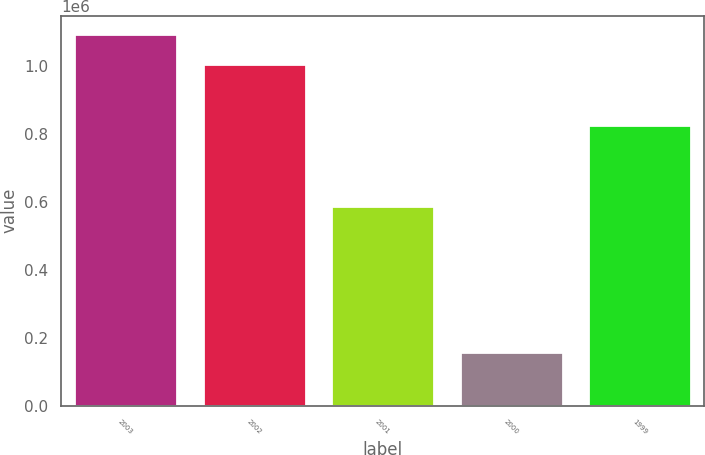Convert chart. <chart><loc_0><loc_0><loc_500><loc_500><bar_chart><fcel>2003<fcel>2002<fcel>2001<fcel>2000<fcel>1999<nl><fcel>1.09425e+06<fcel>1.0085e+06<fcel>588000<fcel>156600<fcel>827050<nl></chart> 